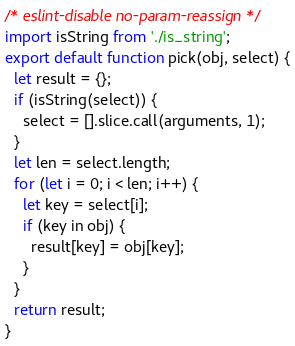Convert code to text. <code><loc_0><loc_0><loc_500><loc_500><_JavaScript_>/* eslint-disable no-param-reassign */
import isString from './is_string';
export default function pick(obj, select) {
  let result = {};
  if (isString(select)) {
    select = [].slice.call(arguments, 1);
  }
  let len = select.length;
  for (let i = 0; i < len; i++) {
    let key = select[i];
    if (key in obj) {
      result[key] = obj[key];
    }
  }
  return result;
}
</code> 